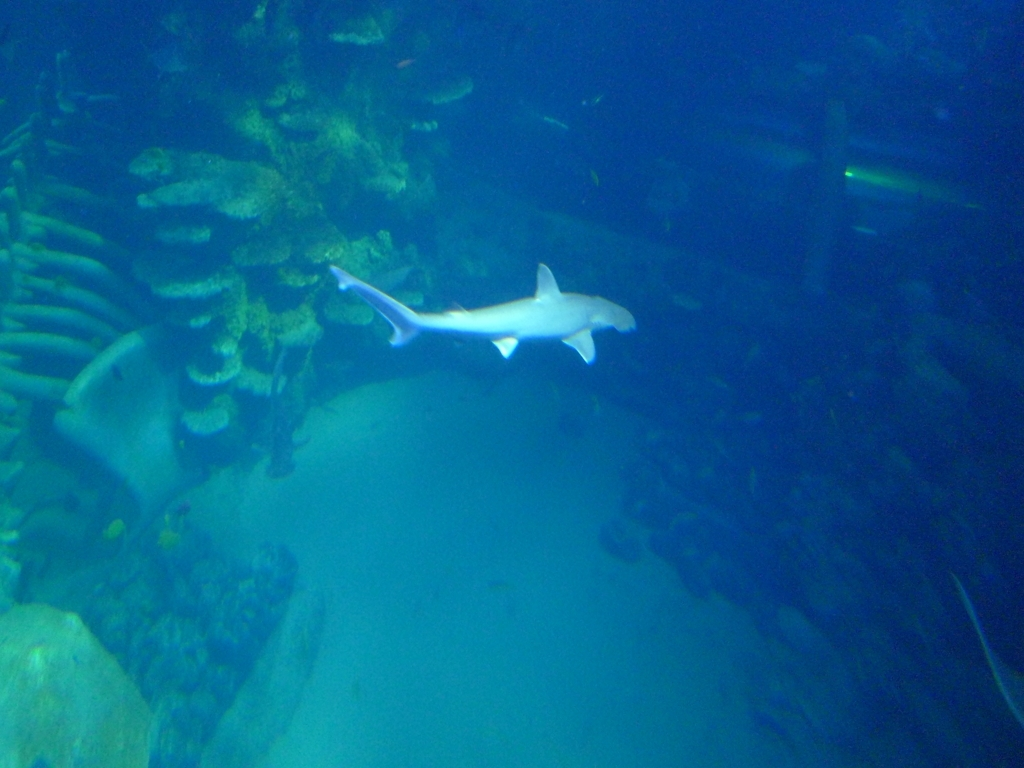Can you tell me more about the type of environment we're looking at in this image? Certainly, the image appears to depict an underwater scene possibly within an oceanic environment. The presence of corals and the aquatic wildlife, such as the shark, suggest a marine habitat that could be part of a natural reef or a large aquarium setup designed to mimic such an ecosystem. 